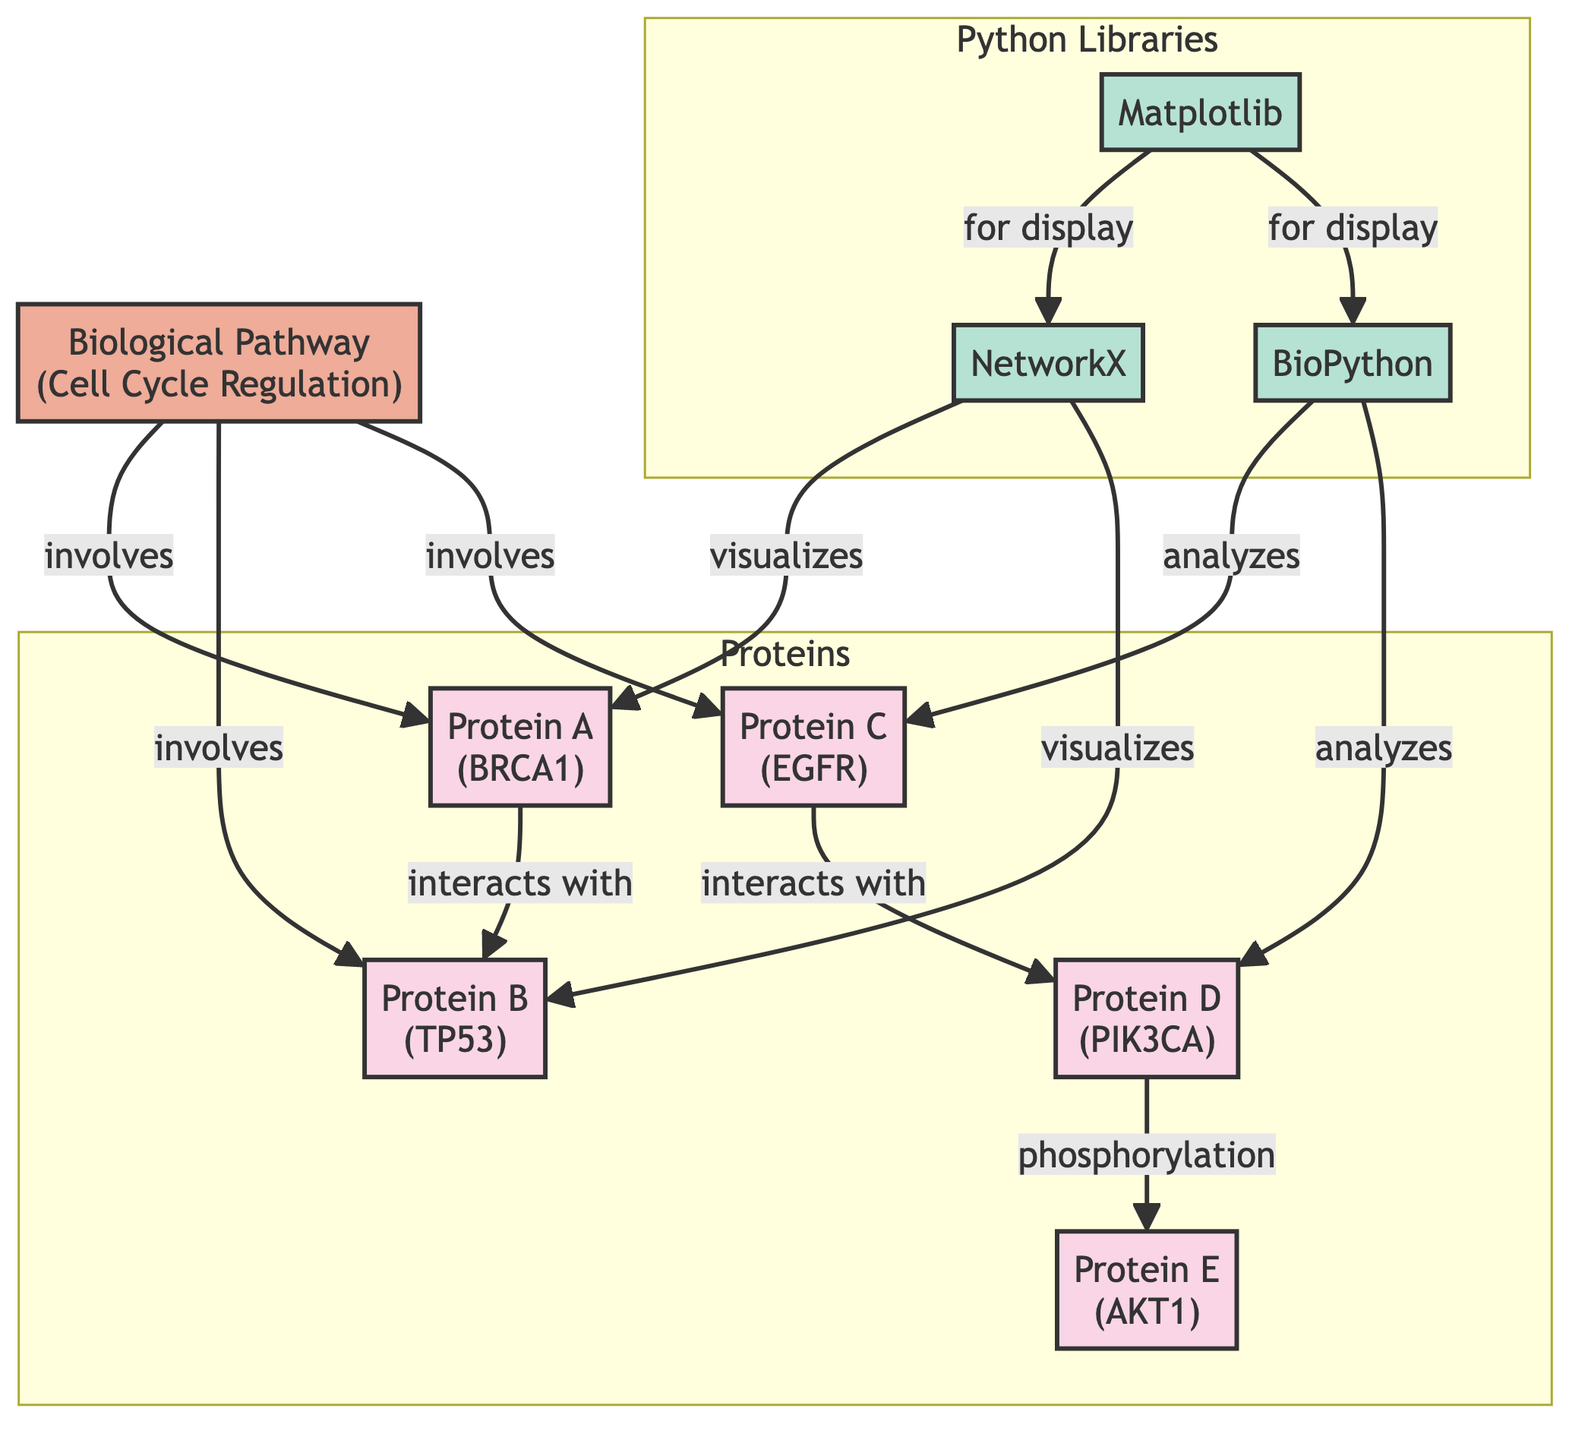What is the total number of proteins depicted in the diagram? The diagram has five nodes that represent proteins: Protein A, Protein B, Protein C, Protein D, and Protein E. Counting these gives a total of five proteins.
Answer: 5 Which protein interacts with Protein A? The diagram shows an arrow indicating that Protein A (BRCA1) interacts with Protein B (TP53).
Answer: Protein B What pathway is associated with the proteins shown in the diagram? The diagram includes one biological pathway labeled "Cell Cycle Regulation" that is connected to multiple proteins.
Answer: Cell Cycle Regulation How many Python libraries are used for visualization and analysis according to the diagram? There are three libraries listed: NetworkX, BioPython, and Matplotlib. Counting these gives a total of three libraries.
Answer: 3 Which protein is involved in the phosphorylation of another protein? The diagram indicates that Protein D (PIK3CA) has a directed link labeled "phosphorylation" pointing to Protein E (AKT1), showing the relationship.
Answer: Protein D Which library is used to visualize the interactions of Protein A? The relationship connecting Protein A (BRCA1) with the library NetworkX in the diagram indicates that NetworkX is used for visualization.
Answer: NetworkX What is the nature of the relationship between the Biological Pathway and Protein B? The diagram shows a connection between the Biological Pathway (Cell Cycle Regulation) and Protein B (TP53) indicating that Protein B is involved in this pathway.
Answer: involves Which library is responsible for display visualizations according to the diagram? The diagram indicates that Matplotlib is used "for display" concerning the visualization libraries represented.
Answer: Matplotlib What type of relationship exists between Protein D and Protein E? The diagram shows a directed edge marked with "phosphorylation" connecting Protein D (PIK3CA) to Protein E (AKT1), indicating a specific type of interaction.
Answer: phosphorylation 